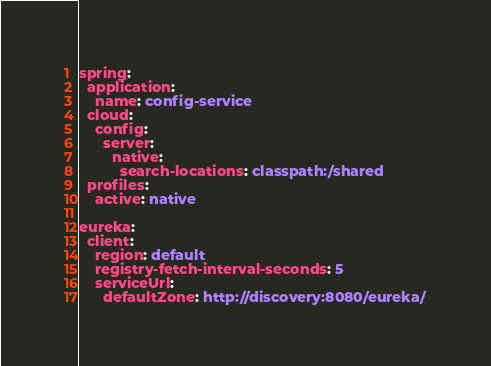Convert code to text. <code><loc_0><loc_0><loc_500><loc_500><_YAML_>spring:
  application:
    name: config-service
  cloud:
    config:
      server:
        native:
          search-locations: classpath:/shared
  profiles:
    active: native

eureka:
  client:
    region: default
    registry-fetch-interval-seconds: 5
    serviceUrl:
      defaultZone: http://discovery:8080/eureka/
</code> 